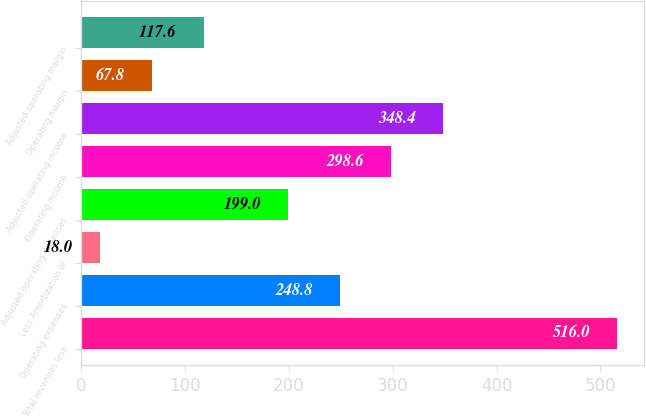Convert chart. <chart><loc_0><loc_0><loc_500><loc_500><bar_chart><fcel>Total revenues less<fcel>Operating expenses<fcel>Less Amortization of<fcel>Adjusted operating expenses<fcel>Operating income<fcel>Adjusted operating income<fcel>Operating margin<fcel>Adjusted operating margin<nl><fcel>516<fcel>248.8<fcel>18<fcel>199<fcel>298.6<fcel>348.4<fcel>67.8<fcel>117.6<nl></chart> 